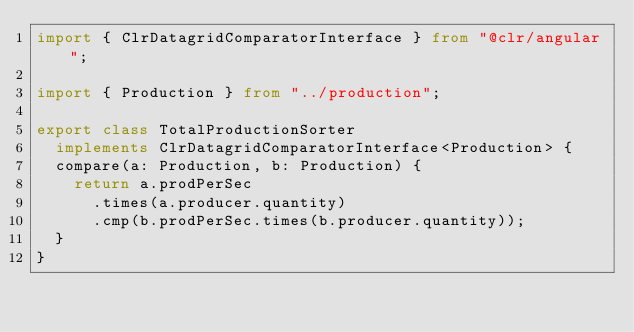<code> <loc_0><loc_0><loc_500><loc_500><_TypeScript_>import { ClrDatagridComparatorInterface } from "@clr/angular";

import { Production } from "../production";

export class TotalProductionSorter
  implements ClrDatagridComparatorInterface<Production> {
  compare(a: Production, b: Production) {
    return a.prodPerSec
      .times(a.producer.quantity)
      .cmp(b.prodPerSec.times(b.producer.quantity));
  }
}
</code> 